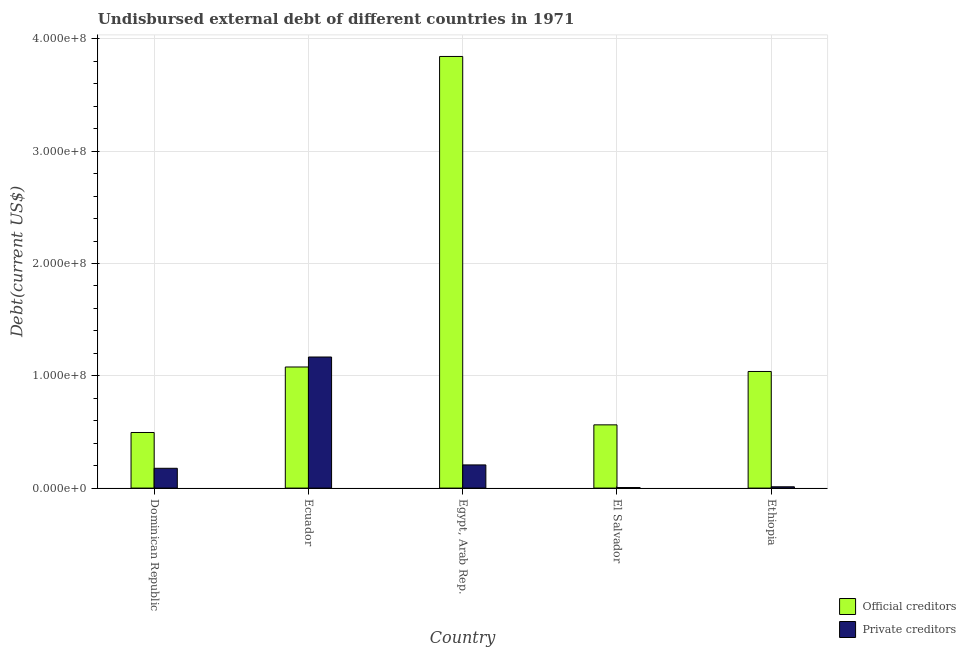How many different coloured bars are there?
Provide a succinct answer. 2. How many groups of bars are there?
Your answer should be very brief. 5. Are the number of bars per tick equal to the number of legend labels?
Provide a short and direct response. Yes. Are the number of bars on each tick of the X-axis equal?
Your answer should be compact. Yes. What is the label of the 4th group of bars from the left?
Give a very brief answer. El Salvador. In how many cases, is the number of bars for a given country not equal to the number of legend labels?
Keep it short and to the point. 0. What is the undisbursed external debt of official creditors in El Salvador?
Give a very brief answer. 5.63e+07. Across all countries, what is the maximum undisbursed external debt of private creditors?
Provide a succinct answer. 1.17e+08. Across all countries, what is the minimum undisbursed external debt of official creditors?
Your answer should be very brief. 4.95e+07. In which country was the undisbursed external debt of private creditors maximum?
Give a very brief answer. Ecuador. In which country was the undisbursed external debt of private creditors minimum?
Keep it short and to the point. El Salvador. What is the total undisbursed external debt of official creditors in the graph?
Provide a succinct answer. 7.02e+08. What is the difference between the undisbursed external debt of private creditors in Dominican Republic and that in Ecuador?
Provide a succinct answer. -9.91e+07. What is the difference between the undisbursed external debt of private creditors in El Salvador and the undisbursed external debt of official creditors in Egypt, Arab Rep.?
Your answer should be compact. -3.84e+08. What is the average undisbursed external debt of official creditors per country?
Make the answer very short. 1.40e+08. What is the difference between the undisbursed external debt of private creditors and undisbursed external debt of official creditors in Ecuador?
Your answer should be very brief. 8.89e+06. What is the ratio of the undisbursed external debt of private creditors in Dominican Republic to that in El Salvador?
Give a very brief answer. 35.26. Is the undisbursed external debt of official creditors in Ecuador less than that in Ethiopia?
Provide a short and direct response. No. Is the difference between the undisbursed external debt of private creditors in Egypt, Arab Rep. and Ethiopia greater than the difference between the undisbursed external debt of official creditors in Egypt, Arab Rep. and Ethiopia?
Your answer should be compact. No. What is the difference between the highest and the second highest undisbursed external debt of private creditors?
Ensure brevity in your answer.  9.61e+07. What is the difference between the highest and the lowest undisbursed external debt of official creditors?
Provide a short and direct response. 3.35e+08. Is the sum of the undisbursed external debt of private creditors in El Salvador and Ethiopia greater than the maximum undisbursed external debt of official creditors across all countries?
Your answer should be compact. No. What does the 2nd bar from the left in Ecuador represents?
Give a very brief answer. Private creditors. What does the 2nd bar from the right in El Salvador represents?
Your answer should be very brief. Official creditors. How many bars are there?
Your answer should be very brief. 10. How many countries are there in the graph?
Your answer should be compact. 5. Are the values on the major ticks of Y-axis written in scientific E-notation?
Keep it short and to the point. Yes. What is the title of the graph?
Ensure brevity in your answer.  Undisbursed external debt of different countries in 1971. What is the label or title of the Y-axis?
Ensure brevity in your answer.  Debt(current US$). What is the Debt(current US$) of Official creditors in Dominican Republic?
Give a very brief answer. 4.95e+07. What is the Debt(current US$) in Private creditors in Dominican Republic?
Provide a short and direct response. 1.76e+07. What is the Debt(current US$) of Official creditors in Ecuador?
Offer a terse response. 1.08e+08. What is the Debt(current US$) of Private creditors in Ecuador?
Provide a succinct answer. 1.17e+08. What is the Debt(current US$) in Official creditors in Egypt, Arab Rep.?
Give a very brief answer. 3.84e+08. What is the Debt(current US$) of Private creditors in Egypt, Arab Rep.?
Provide a succinct answer. 2.06e+07. What is the Debt(current US$) in Official creditors in El Salvador?
Your answer should be compact. 5.63e+07. What is the Debt(current US$) in Official creditors in Ethiopia?
Provide a short and direct response. 1.04e+08. What is the Debt(current US$) of Private creditors in Ethiopia?
Give a very brief answer. 1.16e+06. Across all countries, what is the maximum Debt(current US$) in Official creditors?
Provide a succinct answer. 3.84e+08. Across all countries, what is the maximum Debt(current US$) in Private creditors?
Keep it short and to the point. 1.17e+08. Across all countries, what is the minimum Debt(current US$) of Official creditors?
Ensure brevity in your answer.  4.95e+07. What is the total Debt(current US$) in Official creditors in the graph?
Give a very brief answer. 7.02e+08. What is the total Debt(current US$) in Private creditors in the graph?
Provide a succinct answer. 1.57e+08. What is the difference between the Debt(current US$) in Official creditors in Dominican Republic and that in Ecuador?
Your response must be concise. -5.83e+07. What is the difference between the Debt(current US$) in Private creditors in Dominican Republic and that in Ecuador?
Give a very brief answer. -9.91e+07. What is the difference between the Debt(current US$) of Official creditors in Dominican Republic and that in Egypt, Arab Rep.?
Offer a very short reply. -3.35e+08. What is the difference between the Debt(current US$) in Private creditors in Dominican Republic and that in Egypt, Arab Rep.?
Offer a very short reply. -3.00e+06. What is the difference between the Debt(current US$) in Official creditors in Dominican Republic and that in El Salvador?
Keep it short and to the point. -6.81e+06. What is the difference between the Debt(current US$) in Private creditors in Dominican Republic and that in El Salvador?
Keep it short and to the point. 1.71e+07. What is the difference between the Debt(current US$) of Official creditors in Dominican Republic and that in Ethiopia?
Ensure brevity in your answer.  -5.43e+07. What is the difference between the Debt(current US$) in Private creditors in Dominican Republic and that in Ethiopia?
Your answer should be compact. 1.65e+07. What is the difference between the Debt(current US$) of Official creditors in Ecuador and that in Egypt, Arab Rep.?
Your response must be concise. -2.76e+08. What is the difference between the Debt(current US$) in Private creditors in Ecuador and that in Egypt, Arab Rep.?
Give a very brief answer. 9.61e+07. What is the difference between the Debt(current US$) of Official creditors in Ecuador and that in El Salvador?
Offer a very short reply. 5.15e+07. What is the difference between the Debt(current US$) in Private creditors in Ecuador and that in El Salvador?
Your answer should be compact. 1.16e+08. What is the difference between the Debt(current US$) in Official creditors in Ecuador and that in Ethiopia?
Ensure brevity in your answer.  4.00e+06. What is the difference between the Debt(current US$) in Private creditors in Ecuador and that in Ethiopia?
Offer a terse response. 1.16e+08. What is the difference between the Debt(current US$) of Official creditors in Egypt, Arab Rep. and that in El Salvador?
Keep it short and to the point. 3.28e+08. What is the difference between the Debt(current US$) in Private creditors in Egypt, Arab Rep. and that in El Salvador?
Give a very brief answer. 2.01e+07. What is the difference between the Debt(current US$) in Official creditors in Egypt, Arab Rep. and that in Ethiopia?
Offer a very short reply. 2.80e+08. What is the difference between the Debt(current US$) of Private creditors in Egypt, Arab Rep. and that in Ethiopia?
Your answer should be compact. 1.95e+07. What is the difference between the Debt(current US$) of Official creditors in El Salvador and that in Ethiopia?
Give a very brief answer. -4.75e+07. What is the difference between the Debt(current US$) in Private creditors in El Salvador and that in Ethiopia?
Your response must be concise. -6.65e+05. What is the difference between the Debt(current US$) in Official creditors in Dominican Republic and the Debt(current US$) in Private creditors in Ecuador?
Offer a very short reply. -6.72e+07. What is the difference between the Debt(current US$) in Official creditors in Dominican Republic and the Debt(current US$) in Private creditors in Egypt, Arab Rep.?
Your answer should be compact. 2.89e+07. What is the difference between the Debt(current US$) in Official creditors in Dominican Republic and the Debt(current US$) in Private creditors in El Salvador?
Ensure brevity in your answer.  4.90e+07. What is the difference between the Debt(current US$) of Official creditors in Dominican Republic and the Debt(current US$) of Private creditors in Ethiopia?
Give a very brief answer. 4.83e+07. What is the difference between the Debt(current US$) in Official creditors in Ecuador and the Debt(current US$) in Private creditors in Egypt, Arab Rep.?
Make the answer very short. 8.72e+07. What is the difference between the Debt(current US$) of Official creditors in Ecuador and the Debt(current US$) of Private creditors in El Salvador?
Provide a succinct answer. 1.07e+08. What is the difference between the Debt(current US$) in Official creditors in Ecuador and the Debt(current US$) in Private creditors in Ethiopia?
Make the answer very short. 1.07e+08. What is the difference between the Debt(current US$) in Official creditors in Egypt, Arab Rep. and the Debt(current US$) in Private creditors in El Salvador?
Your response must be concise. 3.84e+08. What is the difference between the Debt(current US$) in Official creditors in Egypt, Arab Rep. and the Debt(current US$) in Private creditors in Ethiopia?
Offer a terse response. 3.83e+08. What is the difference between the Debt(current US$) in Official creditors in El Salvador and the Debt(current US$) in Private creditors in Ethiopia?
Offer a very short reply. 5.51e+07. What is the average Debt(current US$) of Official creditors per country?
Keep it short and to the point. 1.40e+08. What is the average Debt(current US$) in Private creditors per country?
Offer a very short reply. 3.13e+07. What is the difference between the Debt(current US$) in Official creditors and Debt(current US$) in Private creditors in Dominican Republic?
Keep it short and to the point. 3.19e+07. What is the difference between the Debt(current US$) of Official creditors and Debt(current US$) of Private creditors in Ecuador?
Make the answer very short. -8.89e+06. What is the difference between the Debt(current US$) in Official creditors and Debt(current US$) in Private creditors in Egypt, Arab Rep.?
Make the answer very short. 3.64e+08. What is the difference between the Debt(current US$) in Official creditors and Debt(current US$) in Private creditors in El Salvador?
Offer a very short reply. 5.58e+07. What is the difference between the Debt(current US$) in Official creditors and Debt(current US$) in Private creditors in Ethiopia?
Your answer should be very brief. 1.03e+08. What is the ratio of the Debt(current US$) of Official creditors in Dominican Republic to that in Ecuador?
Your answer should be very brief. 0.46. What is the ratio of the Debt(current US$) in Private creditors in Dominican Republic to that in Ecuador?
Provide a short and direct response. 0.15. What is the ratio of the Debt(current US$) of Official creditors in Dominican Republic to that in Egypt, Arab Rep.?
Make the answer very short. 0.13. What is the ratio of the Debt(current US$) in Private creditors in Dominican Republic to that in Egypt, Arab Rep.?
Provide a short and direct response. 0.85. What is the ratio of the Debt(current US$) of Official creditors in Dominican Republic to that in El Salvador?
Your response must be concise. 0.88. What is the ratio of the Debt(current US$) in Private creditors in Dominican Republic to that in El Salvador?
Your answer should be compact. 35.26. What is the ratio of the Debt(current US$) in Official creditors in Dominican Republic to that in Ethiopia?
Give a very brief answer. 0.48. What is the ratio of the Debt(current US$) of Private creditors in Dominican Republic to that in Ethiopia?
Keep it short and to the point. 15.13. What is the ratio of the Debt(current US$) of Official creditors in Ecuador to that in Egypt, Arab Rep.?
Keep it short and to the point. 0.28. What is the ratio of the Debt(current US$) in Private creditors in Ecuador to that in Egypt, Arab Rep.?
Ensure brevity in your answer.  5.66. What is the ratio of the Debt(current US$) in Official creditors in Ecuador to that in El Salvador?
Provide a short and direct response. 1.91. What is the ratio of the Debt(current US$) in Private creditors in Ecuador to that in El Salvador?
Your answer should be very brief. 233.43. What is the ratio of the Debt(current US$) in Official creditors in Ecuador to that in Ethiopia?
Keep it short and to the point. 1.04. What is the ratio of the Debt(current US$) in Private creditors in Ecuador to that in Ethiopia?
Your answer should be compact. 100.19. What is the ratio of the Debt(current US$) in Official creditors in Egypt, Arab Rep. to that in El Salvador?
Your answer should be compact. 6.82. What is the ratio of the Debt(current US$) of Private creditors in Egypt, Arab Rep. to that in El Salvador?
Offer a very short reply. 41.27. What is the ratio of the Debt(current US$) in Official creditors in Egypt, Arab Rep. to that in Ethiopia?
Your response must be concise. 3.7. What is the ratio of the Debt(current US$) of Private creditors in Egypt, Arab Rep. to that in Ethiopia?
Provide a short and direct response. 17.71. What is the ratio of the Debt(current US$) in Official creditors in El Salvador to that in Ethiopia?
Offer a terse response. 0.54. What is the ratio of the Debt(current US$) of Private creditors in El Salvador to that in Ethiopia?
Your answer should be compact. 0.43. What is the difference between the highest and the second highest Debt(current US$) in Official creditors?
Your answer should be very brief. 2.76e+08. What is the difference between the highest and the second highest Debt(current US$) of Private creditors?
Your answer should be very brief. 9.61e+07. What is the difference between the highest and the lowest Debt(current US$) of Official creditors?
Keep it short and to the point. 3.35e+08. What is the difference between the highest and the lowest Debt(current US$) of Private creditors?
Provide a short and direct response. 1.16e+08. 